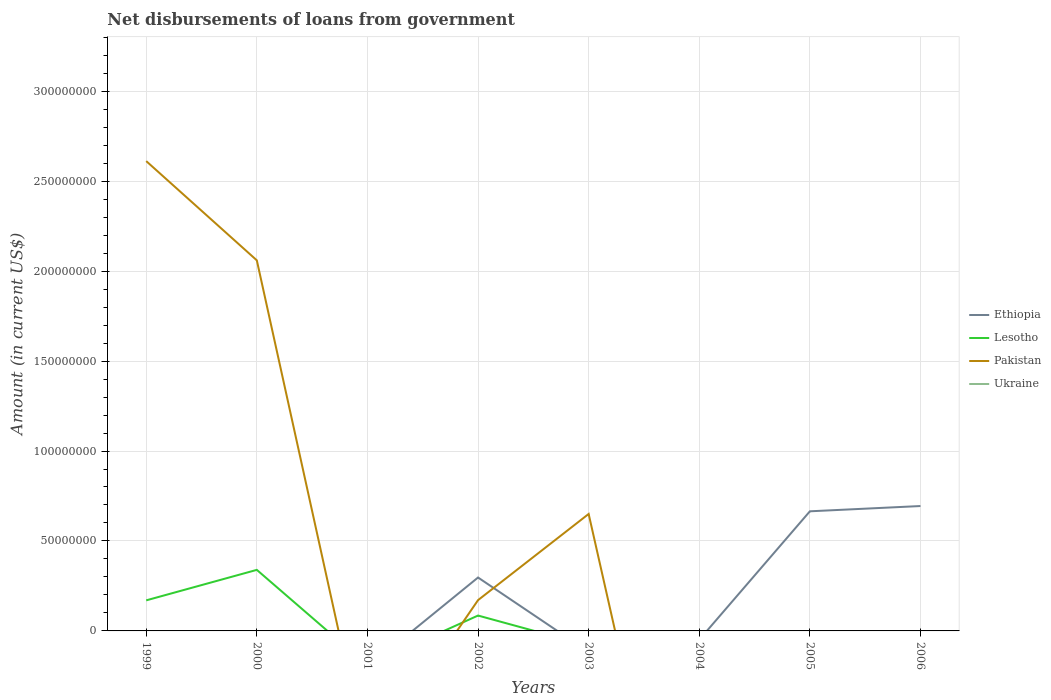How many different coloured lines are there?
Your answer should be very brief. 3. Does the line corresponding to Pakistan intersect with the line corresponding to Ukraine?
Keep it short and to the point. Yes. Across all years, what is the maximum amount of loan disbursed from government in Pakistan?
Give a very brief answer. 0. What is the total amount of loan disbursed from government in Lesotho in the graph?
Ensure brevity in your answer.  2.54e+07. What is the difference between the highest and the second highest amount of loan disbursed from government in Ethiopia?
Keep it short and to the point. 6.94e+07. What is the difference between the highest and the lowest amount of loan disbursed from government in Ukraine?
Ensure brevity in your answer.  0. Is the amount of loan disbursed from government in Pakistan strictly greater than the amount of loan disbursed from government in Lesotho over the years?
Keep it short and to the point. No. How many years are there in the graph?
Provide a short and direct response. 8. What is the difference between two consecutive major ticks on the Y-axis?
Your answer should be compact. 5.00e+07. Are the values on the major ticks of Y-axis written in scientific E-notation?
Make the answer very short. No. Does the graph contain grids?
Your response must be concise. Yes. Where does the legend appear in the graph?
Your response must be concise. Center right. How are the legend labels stacked?
Offer a very short reply. Vertical. What is the title of the graph?
Make the answer very short. Net disbursements of loans from government. Does "Myanmar" appear as one of the legend labels in the graph?
Provide a short and direct response. No. What is the label or title of the X-axis?
Provide a short and direct response. Years. What is the label or title of the Y-axis?
Your response must be concise. Amount (in current US$). What is the Amount (in current US$) of Ethiopia in 1999?
Keep it short and to the point. 0. What is the Amount (in current US$) in Lesotho in 1999?
Your response must be concise. 1.70e+07. What is the Amount (in current US$) of Pakistan in 1999?
Your answer should be compact. 2.61e+08. What is the Amount (in current US$) in Ukraine in 1999?
Make the answer very short. 0. What is the Amount (in current US$) in Ethiopia in 2000?
Your response must be concise. 0. What is the Amount (in current US$) of Lesotho in 2000?
Ensure brevity in your answer.  3.39e+07. What is the Amount (in current US$) of Pakistan in 2000?
Offer a very short reply. 2.06e+08. What is the Amount (in current US$) of Ethiopia in 2001?
Make the answer very short. 0. What is the Amount (in current US$) in Pakistan in 2001?
Keep it short and to the point. 0. What is the Amount (in current US$) of Ukraine in 2001?
Give a very brief answer. 0. What is the Amount (in current US$) in Ethiopia in 2002?
Keep it short and to the point. 2.97e+07. What is the Amount (in current US$) in Lesotho in 2002?
Offer a very short reply. 8.55e+06. What is the Amount (in current US$) in Pakistan in 2002?
Your response must be concise. 1.71e+07. What is the Amount (in current US$) of Ukraine in 2002?
Your answer should be very brief. 0. What is the Amount (in current US$) in Ethiopia in 2003?
Your response must be concise. 0. What is the Amount (in current US$) of Pakistan in 2003?
Make the answer very short. 6.50e+07. What is the Amount (in current US$) of Ukraine in 2003?
Provide a short and direct response. 0. What is the Amount (in current US$) of Pakistan in 2004?
Provide a succinct answer. 0. What is the Amount (in current US$) of Ethiopia in 2005?
Offer a very short reply. 6.65e+07. What is the Amount (in current US$) in Lesotho in 2005?
Provide a short and direct response. 0. What is the Amount (in current US$) in Pakistan in 2005?
Ensure brevity in your answer.  0. What is the Amount (in current US$) in Ukraine in 2005?
Keep it short and to the point. 0. What is the Amount (in current US$) of Ethiopia in 2006?
Provide a short and direct response. 6.94e+07. What is the Amount (in current US$) in Pakistan in 2006?
Make the answer very short. 0. What is the Amount (in current US$) in Ukraine in 2006?
Offer a terse response. 0. Across all years, what is the maximum Amount (in current US$) of Ethiopia?
Your answer should be compact. 6.94e+07. Across all years, what is the maximum Amount (in current US$) of Lesotho?
Make the answer very short. 3.39e+07. Across all years, what is the maximum Amount (in current US$) in Pakistan?
Ensure brevity in your answer.  2.61e+08. Across all years, what is the minimum Amount (in current US$) of Ethiopia?
Offer a terse response. 0. What is the total Amount (in current US$) of Ethiopia in the graph?
Give a very brief answer. 1.66e+08. What is the total Amount (in current US$) in Lesotho in the graph?
Provide a succinct answer. 5.95e+07. What is the total Amount (in current US$) of Pakistan in the graph?
Provide a succinct answer. 5.49e+08. What is the difference between the Amount (in current US$) of Lesotho in 1999 and that in 2000?
Your answer should be very brief. -1.69e+07. What is the difference between the Amount (in current US$) in Pakistan in 1999 and that in 2000?
Keep it short and to the point. 5.52e+07. What is the difference between the Amount (in current US$) in Lesotho in 1999 and that in 2002?
Make the answer very short. 8.44e+06. What is the difference between the Amount (in current US$) in Pakistan in 1999 and that in 2002?
Give a very brief answer. 2.44e+08. What is the difference between the Amount (in current US$) in Pakistan in 1999 and that in 2003?
Offer a very short reply. 1.96e+08. What is the difference between the Amount (in current US$) in Lesotho in 2000 and that in 2002?
Make the answer very short. 2.54e+07. What is the difference between the Amount (in current US$) of Pakistan in 2000 and that in 2002?
Provide a short and direct response. 1.89e+08. What is the difference between the Amount (in current US$) of Pakistan in 2000 and that in 2003?
Give a very brief answer. 1.41e+08. What is the difference between the Amount (in current US$) in Pakistan in 2002 and that in 2003?
Make the answer very short. -4.79e+07. What is the difference between the Amount (in current US$) in Ethiopia in 2002 and that in 2005?
Your response must be concise. -3.68e+07. What is the difference between the Amount (in current US$) in Ethiopia in 2002 and that in 2006?
Provide a short and direct response. -3.97e+07. What is the difference between the Amount (in current US$) of Ethiopia in 2005 and that in 2006?
Offer a terse response. -2.93e+06. What is the difference between the Amount (in current US$) in Lesotho in 1999 and the Amount (in current US$) in Pakistan in 2000?
Provide a succinct answer. -1.89e+08. What is the difference between the Amount (in current US$) in Lesotho in 1999 and the Amount (in current US$) in Pakistan in 2002?
Provide a short and direct response. -1.27e+05. What is the difference between the Amount (in current US$) in Lesotho in 1999 and the Amount (in current US$) in Pakistan in 2003?
Keep it short and to the point. -4.80e+07. What is the difference between the Amount (in current US$) in Lesotho in 2000 and the Amount (in current US$) in Pakistan in 2002?
Ensure brevity in your answer.  1.68e+07. What is the difference between the Amount (in current US$) in Lesotho in 2000 and the Amount (in current US$) in Pakistan in 2003?
Offer a very short reply. -3.11e+07. What is the difference between the Amount (in current US$) in Ethiopia in 2002 and the Amount (in current US$) in Pakistan in 2003?
Your response must be concise. -3.53e+07. What is the difference between the Amount (in current US$) in Lesotho in 2002 and the Amount (in current US$) in Pakistan in 2003?
Give a very brief answer. -5.65e+07. What is the average Amount (in current US$) of Ethiopia per year?
Make the answer very short. 2.07e+07. What is the average Amount (in current US$) of Lesotho per year?
Provide a short and direct response. 7.43e+06. What is the average Amount (in current US$) in Pakistan per year?
Give a very brief answer. 6.87e+07. What is the average Amount (in current US$) in Ukraine per year?
Provide a short and direct response. 0. In the year 1999, what is the difference between the Amount (in current US$) of Lesotho and Amount (in current US$) of Pakistan?
Offer a very short reply. -2.44e+08. In the year 2000, what is the difference between the Amount (in current US$) in Lesotho and Amount (in current US$) in Pakistan?
Your answer should be compact. -1.72e+08. In the year 2002, what is the difference between the Amount (in current US$) in Ethiopia and Amount (in current US$) in Lesotho?
Offer a very short reply. 2.11e+07. In the year 2002, what is the difference between the Amount (in current US$) of Ethiopia and Amount (in current US$) of Pakistan?
Provide a succinct answer. 1.26e+07. In the year 2002, what is the difference between the Amount (in current US$) in Lesotho and Amount (in current US$) in Pakistan?
Keep it short and to the point. -8.57e+06. What is the ratio of the Amount (in current US$) of Lesotho in 1999 to that in 2000?
Give a very brief answer. 0.5. What is the ratio of the Amount (in current US$) of Pakistan in 1999 to that in 2000?
Provide a succinct answer. 1.27. What is the ratio of the Amount (in current US$) in Lesotho in 1999 to that in 2002?
Ensure brevity in your answer.  1.99. What is the ratio of the Amount (in current US$) of Pakistan in 1999 to that in 2002?
Provide a succinct answer. 15.26. What is the ratio of the Amount (in current US$) of Pakistan in 1999 to that in 2003?
Keep it short and to the point. 4.02. What is the ratio of the Amount (in current US$) of Lesotho in 2000 to that in 2002?
Offer a terse response. 3.97. What is the ratio of the Amount (in current US$) of Pakistan in 2000 to that in 2002?
Your response must be concise. 12.04. What is the ratio of the Amount (in current US$) of Pakistan in 2000 to that in 2003?
Provide a short and direct response. 3.17. What is the ratio of the Amount (in current US$) in Pakistan in 2002 to that in 2003?
Offer a very short reply. 0.26. What is the ratio of the Amount (in current US$) of Ethiopia in 2002 to that in 2005?
Offer a very short reply. 0.45. What is the ratio of the Amount (in current US$) of Ethiopia in 2002 to that in 2006?
Make the answer very short. 0.43. What is the ratio of the Amount (in current US$) of Ethiopia in 2005 to that in 2006?
Offer a very short reply. 0.96. What is the difference between the highest and the second highest Amount (in current US$) in Ethiopia?
Give a very brief answer. 2.93e+06. What is the difference between the highest and the second highest Amount (in current US$) of Lesotho?
Give a very brief answer. 1.69e+07. What is the difference between the highest and the second highest Amount (in current US$) of Pakistan?
Offer a very short reply. 5.52e+07. What is the difference between the highest and the lowest Amount (in current US$) of Ethiopia?
Offer a terse response. 6.94e+07. What is the difference between the highest and the lowest Amount (in current US$) in Lesotho?
Provide a succinct answer. 3.39e+07. What is the difference between the highest and the lowest Amount (in current US$) of Pakistan?
Offer a very short reply. 2.61e+08. 